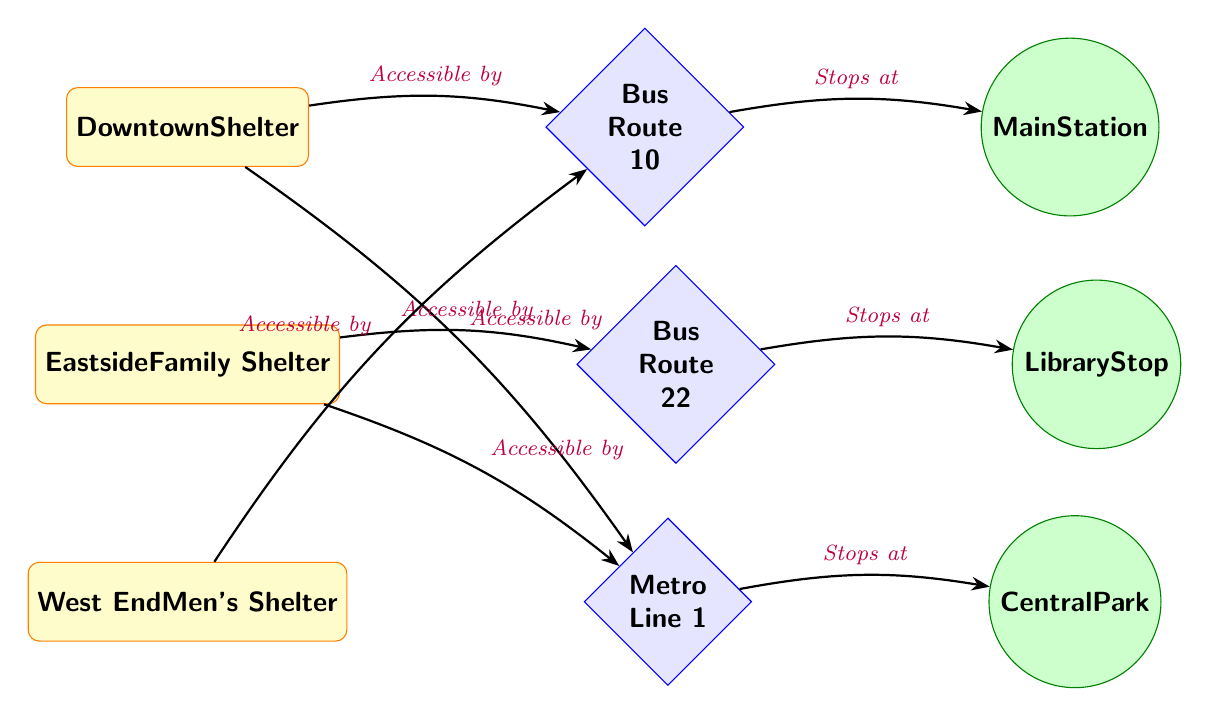What shelters are located in the diagram? The diagram displays three shelters: Downtown Shelter, Eastside Family Shelter, and West End Men's Shelter.
Answer: Downtown Shelter, Eastside Family Shelter, West End Men's Shelter Which bus route is associated with the Downtown Shelter? The Downtown Shelter is connected to Bus Route 10, as evidenced by the arrow labeled "Accessible by".
Answer: Bus Route 10 How many transportation nodes are present in the diagram? There are three transportation nodes indicated: Bus Route 10, Bus Route 22, and Metro Line 1. Counting these, we find three transportation nodes.
Answer: 3 Which shelter is accessible by Metro Line 1? Metro Line 1 is accessible by the Downtown Shelter and the West End Men's Shelter, as indicated by the arrows linking them.
Answer: Downtown Shelter, West End Men's Shelter What landmark does Bus Route 22 stop at? Bus Route 22 stops at the Library Stop, as shown by the edge with the label "Stops at".
Answer: Library Stop What is the relationship between the Eastside Family Shelter and Metro Line 1? The Eastside Family Shelter is connected to Metro Line 1 via the arrow labeled "Accessible by", indicating a direct access.
Answer: Accessible How many edges are in the diagram indicating accessibility? The diagram contains five edges that demonstrate accessibility between shelters and transportation nodes. Counting these edges gives five.
Answer: 5 Which two shelters are accessible by Bus Route 10? Both the Downtown Shelter and the West End Men's Shelter are accessible by Bus Route 10, indicated by the arrows showing the connection.
Answer: Downtown Shelter, West End Men's Shelter Which shelter is connected to the Main Station? The Downtown Shelter has an edge leading to Bus Route 10, which in turn connects to the Main Station, thus making this connection evident.
Answer: Downtown Shelter 